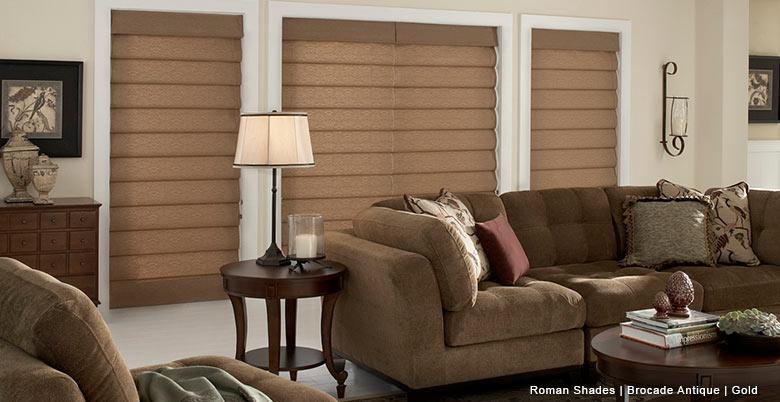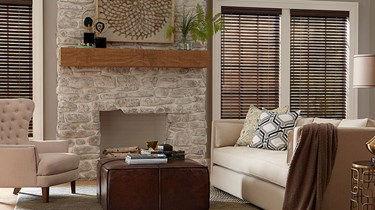The first image is the image on the left, the second image is the image on the right. Evaluate the accuracy of this statement regarding the images: "All the window shades are partially up.". Is it true? Answer yes or no. No. 